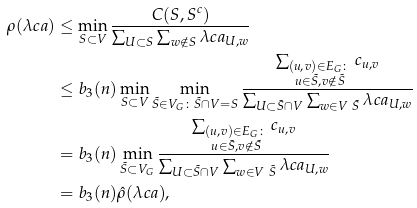Convert formula to latex. <formula><loc_0><loc_0><loc_500><loc_500>\rho ( \lambda c a ) & \leq \min _ { S \subset V } \frac { C ( S , S ^ { c } ) } { \sum _ { U \subset S } \sum _ { w \notin S } \lambda c a _ { U , w } } \\ & \leq b _ { 3 } ( n ) \min _ { S \subset V } \min _ { \tilde { S } \in V _ { G } \colon \tilde { S } \cap V = S } \frac { \sum _ { \substack { ( u , v ) \in E _ { G } \colon \\ u \in \tilde { S } , v \notin \tilde { S } } } c _ { u , v } } { \sum _ { U \subset \tilde { S } \cap V } \sum _ { w \in V \ \tilde { S } } \lambda c a _ { U , w } } \\ & = b _ { 3 } ( n ) \min _ { \tilde { S } \subset V _ { G } } \frac { \sum _ { \substack { ( u , v ) \in E _ { G } \colon \\ u \in \tilde { S } , v \notin \tilde { S } } } c _ { u , v } } { \sum _ { U \subset \tilde { S } \cap V } \sum _ { w \in V \ \tilde { S } } \lambda c a _ { U , w } } \\ & = b _ { 3 } ( n ) \hat { \rho } ( \lambda c a ) ,</formula> 